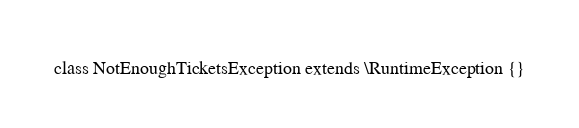Convert code to text. <code><loc_0><loc_0><loc_500><loc_500><_PHP_>class NotEnoughTicketsException extends \RuntimeException {}</code> 